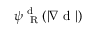<formula> <loc_0><loc_0><loc_500><loc_500>\psi _ { R } ^ { d } ( | \nabla d | )</formula> 